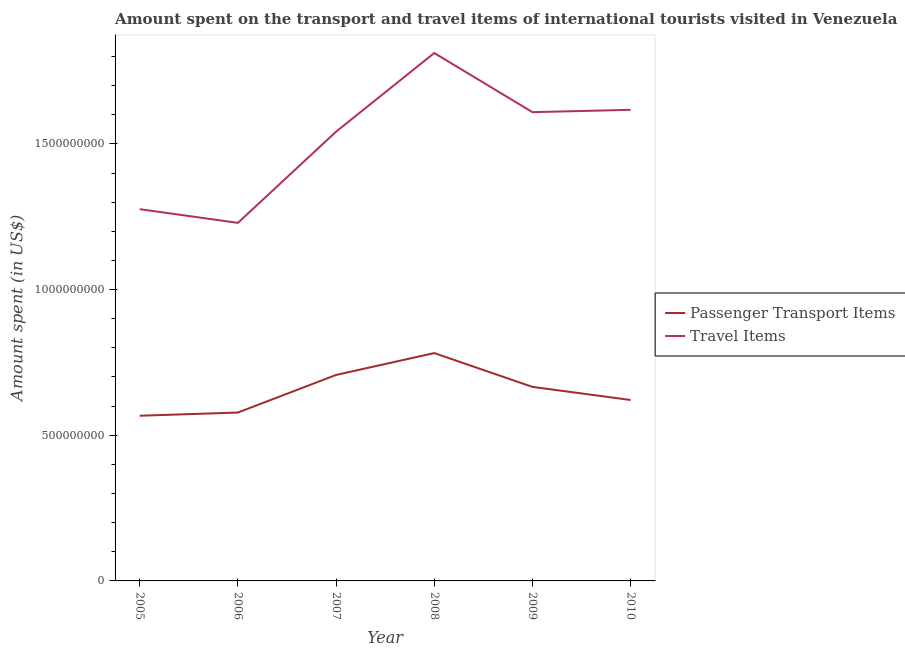Does the line corresponding to amount spent on passenger transport items intersect with the line corresponding to amount spent in travel items?
Make the answer very short. No. Is the number of lines equal to the number of legend labels?
Provide a short and direct response. Yes. What is the amount spent in travel items in 2010?
Provide a succinct answer. 1.62e+09. Across all years, what is the maximum amount spent in travel items?
Give a very brief answer. 1.81e+09. Across all years, what is the minimum amount spent on passenger transport items?
Your answer should be compact. 5.67e+08. In which year was the amount spent on passenger transport items maximum?
Provide a succinct answer. 2008. What is the total amount spent on passenger transport items in the graph?
Your response must be concise. 3.92e+09. What is the difference between the amount spent in travel items in 2005 and that in 2009?
Ensure brevity in your answer.  -3.33e+08. What is the difference between the amount spent in travel items in 2006 and the amount spent on passenger transport items in 2009?
Provide a succinct answer. 5.63e+08. What is the average amount spent in travel items per year?
Offer a very short reply. 1.51e+09. In the year 2009, what is the difference between the amount spent on passenger transport items and amount spent in travel items?
Your answer should be compact. -9.43e+08. What is the ratio of the amount spent on passenger transport items in 2005 to that in 2009?
Your answer should be very brief. 0.85. What is the difference between the highest and the second highest amount spent on passenger transport items?
Provide a short and direct response. 7.50e+07. What is the difference between the highest and the lowest amount spent in travel items?
Offer a very short reply. 5.83e+08. Is the sum of the amount spent in travel items in 2006 and 2008 greater than the maximum amount spent on passenger transport items across all years?
Make the answer very short. Yes. Is the amount spent in travel items strictly less than the amount spent on passenger transport items over the years?
Provide a short and direct response. No. How many years are there in the graph?
Give a very brief answer. 6. Are the values on the major ticks of Y-axis written in scientific E-notation?
Make the answer very short. No. Where does the legend appear in the graph?
Your answer should be very brief. Center right. How are the legend labels stacked?
Keep it short and to the point. Vertical. What is the title of the graph?
Provide a succinct answer. Amount spent on the transport and travel items of international tourists visited in Venezuela. What is the label or title of the Y-axis?
Make the answer very short. Amount spent (in US$). What is the Amount spent (in US$) of Passenger Transport Items in 2005?
Keep it short and to the point. 5.67e+08. What is the Amount spent (in US$) in Travel Items in 2005?
Make the answer very short. 1.28e+09. What is the Amount spent (in US$) in Passenger Transport Items in 2006?
Provide a succinct answer. 5.78e+08. What is the Amount spent (in US$) in Travel Items in 2006?
Provide a short and direct response. 1.23e+09. What is the Amount spent (in US$) of Passenger Transport Items in 2007?
Offer a terse response. 7.07e+08. What is the Amount spent (in US$) in Travel Items in 2007?
Provide a short and direct response. 1.54e+09. What is the Amount spent (in US$) in Passenger Transport Items in 2008?
Offer a very short reply. 7.82e+08. What is the Amount spent (in US$) in Travel Items in 2008?
Offer a very short reply. 1.81e+09. What is the Amount spent (in US$) of Passenger Transport Items in 2009?
Your response must be concise. 6.66e+08. What is the Amount spent (in US$) of Travel Items in 2009?
Give a very brief answer. 1.61e+09. What is the Amount spent (in US$) in Passenger Transport Items in 2010?
Provide a short and direct response. 6.21e+08. What is the Amount spent (in US$) in Travel Items in 2010?
Your answer should be compact. 1.62e+09. Across all years, what is the maximum Amount spent (in US$) in Passenger Transport Items?
Provide a short and direct response. 7.82e+08. Across all years, what is the maximum Amount spent (in US$) in Travel Items?
Your answer should be compact. 1.81e+09. Across all years, what is the minimum Amount spent (in US$) in Passenger Transport Items?
Your response must be concise. 5.67e+08. Across all years, what is the minimum Amount spent (in US$) of Travel Items?
Provide a succinct answer. 1.23e+09. What is the total Amount spent (in US$) of Passenger Transport Items in the graph?
Your response must be concise. 3.92e+09. What is the total Amount spent (in US$) in Travel Items in the graph?
Give a very brief answer. 9.08e+09. What is the difference between the Amount spent (in US$) of Passenger Transport Items in 2005 and that in 2006?
Keep it short and to the point. -1.10e+07. What is the difference between the Amount spent (in US$) in Travel Items in 2005 and that in 2006?
Keep it short and to the point. 4.70e+07. What is the difference between the Amount spent (in US$) in Passenger Transport Items in 2005 and that in 2007?
Provide a succinct answer. -1.40e+08. What is the difference between the Amount spent (in US$) of Travel Items in 2005 and that in 2007?
Make the answer very short. -2.66e+08. What is the difference between the Amount spent (in US$) in Passenger Transport Items in 2005 and that in 2008?
Make the answer very short. -2.15e+08. What is the difference between the Amount spent (in US$) in Travel Items in 2005 and that in 2008?
Give a very brief answer. -5.36e+08. What is the difference between the Amount spent (in US$) of Passenger Transport Items in 2005 and that in 2009?
Make the answer very short. -9.90e+07. What is the difference between the Amount spent (in US$) in Travel Items in 2005 and that in 2009?
Your answer should be compact. -3.33e+08. What is the difference between the Amount spent (in US$) in Passenger Transport Items in 2005 and that in 2010?
Provide a short and direct response. -5.40e+07. What is the difference between the Amount spent (in US$) in Travel Items in 2005 and that in 2010?
Offer a very short reply. -3.41e+08. What is the difference between the Amount spent (in US$) in Passenger Transport Items in 2006 and that in 2007?
Offer a terse response. -1.29e+08. What is the difference between the Amount spent (in US$) of Travel Items in 2006 and that in 2007?
Your answer should be very brief. -3.13e+08. What is the difference between the Amount spent (in US$) of Passenger Transport Items in 2006 and that in 2008?
Provide a succinct answer. -2.04e+08. What is the difference between the Amount spent (in US$) in Travel Items in 2006 and that in 2008?
Give a very brief answer. -5.83e+08. What is the difference between the Amount spent (in US$) of Passenger Transport Items in 2006 and that in 2009?
Offer a terse response. -8.80e+07. What is the difference between the Amount spent (in US$) of Travel Items in 2006 and that in 2009?
Provide a succinct answer. -3.80e+08. What is the difference between the Amount spent (in US$) in Passenger Transport Items in 2006 and that in 2010?
Keep it short and to the point. -4.30e+07. What is the difference between the Amount spent (in US$) in Travel Items in 2006 and that in 2010?
Provide a succinct answer. -3.88e+08. What is the difference between the Amount spent (in US$) in Passenger Transport Items in 2007 and that in 2008?
Your response must be concise. -7.50e+07. What is the difference between the Amount spent (in US$) in Travel Items in 2007 and that in 2008?
Provide a succinct answer. -2.70e+08. What is the difference between the Amount spent (in US$) of Passenger Transport Items in 2007 and that in 2009?
Your response must be concise. 4.10e+07. What is the difference between the Amount spent (in US$) of Travel Items in 2007 and that in 2009?
Your answer should be compact. -6.70e+07. What is the difference between the Amount spent (in US$) in Passenger Transport Items in 2007 and that in 2010?
Provide a succinct answer. 8.60e+07. What is the difference between the Amount spent (in US$) of Travel Items in 2007 and that in 2010?
Offer a very short reply. -7.50e+07. What is the difference between the Amount spent (in US$) of Passenger Transport Items in 2008 and that in 2009?
Provide a short and direct response. 1.16e+08. What is the difference between the Amount spent (in US$) in Travel Items in 2008 and that in 2009?
Keep it short and to the point. 2.03e+08. What is the difference between the Amount spent (in US$) of Passenger Transport Items in 2008 and that in 2010?
Keep it short and to the point. 1.61e+08. What is the difference between the Amount spent (in US$) in Travel Items in 2008 and that in 2010?
Keep it short and to the point. 1.95e+08. What is the difference between the Amount spent (in US$) in Passenger Transport Items in 2009 and that in 2010?
Your response must be concise. 4.50e+07. What is the difference between the Amount spent (in US$) in Travel Items in 2009 and that in 2010?
Your answer should be very brief. -8.00e+06. What is the difference between the Amount spent (in US$) in Passenger Transport Items in 2005 and the Amount spent (in US$) in Travel Items in 2006?
Your answer should be compact. -6.62e+08. What is the difference between the Amount spent (in US$) in Passenger Transport Items in 2005 and the Amount spent (in US$) in Travel Items in 2007?
Your answer should be compact. -9.75e+08. What is the difference between the Amount spent (in US$) of Passenger Transport Items in 2005 and the Amount spent (in US$) of Travel Items in 2008?
Offer a very short reply. -1.24e+09. What is the difference between the Amount spent (in US$) of Passenger Transport Items in 2005 and the Amount spent (in US$) of Travel Items in 2009?
Provide a short and direct response. -1.04e+09. What is the difference between the Amount spent (in US$) of Passenger Transport Items in 2005 and the Amount spent (in US$) of Travel Items in 2010?
Provide a succinct answer. -1.05e+09. What is the difference between the Amount spent (in US$) of Passenger Transport Items in 2006 and the Amount spent (in US$) of Travel Items in 2007?
Ensure brevity in your answer.  -9.64e+08. What is the difference between the Amount spent (in US$) of Passenger Transport Items in 2006 and the Amount spent (in US$) of Travel Items in 2008?
Make the answer very short. -1.23e+09. What is the difference between the Amount spent (in US$) in Passenger Transport Items in 2006 and the Amount spent (in US$) in Travel Items in 2009?
Keep it short and to the point. -1.03e+09. What is the difference between the Amount spent (in US$) of Passenger Transport Items in 2006 and the Amount spent (in US$) of Travel Items in 2010?
Your answer should be compact. -1.04e+09. What is the difference between the Amount spent (in US$) in Passenger Transport Items in 2007 and the Amount spent (in US$) in Travel Items in 2008?
Make the answer very short. -1.10e+09. What is the difference between the Amount spent (in US$) in Passenger Transport Items in 2007 and the Amount spent (in US$) in Travel Items in 2009?
Your answer should be very brief. -9.02e+08. What is the difference between the Amount spent (in US$) of Passenger Transport Items in 2007 and the Amount spent (in US$) of Travel Items in 2010?
Your response must be concise. -9.10e+08. What is the difference between the Amount spent (in US$) in Passenger Transport Items in 2008 and the Amount spent (in US$) in Travel Items in 2009?
Your answer should be compact. -8.27e+08. What is the difference between the Amount spent (in US$) of Passenger Transport Items in 2008 and the Amount spent (in US$) of Travel Items in 2010?
Give a very brief answer. -8.35e+08. What is the difference between the Amount spent (in US$) in Passenger Transport Items in 2009 and the Amount spent (in US$) in Travel Items in 2010?
Provide a short and direct response. -9.51e+08. What is the average Amount spent (in US$) in Passenger Transport Items per year?
Offer a very short reply. 6.54e+08. What is the average Amount spent (in US$) of Travel Items per year?
Provide a short and direct response. 1.51e+09. In the year 2005, what is the difference between the Amount spent (in US$) of Passenger Transport Items and Amount spent (in US$) of Travel Items?
Your response must be concise. -7.09e+08. In the year 2006, what is the difference between the Amount spent (in US$) in Passenger Transport Items and Amount spent (in US$) in Travel Items?
Keep it short and to the point. -6.51e+08. In the year 2007, what is the difference between the Amount spent (in US$) of Passenger Transport Items and Amount spent (in US$) of Travel Items?
Provide a short and direct response. -8.35e+08. In the year 2008, what is the difference between the Amount spent (in US$) of Passenger Transport Items and Amount spent (in US$) of Travel Items?
Keep it short and to the point. -1.03e+09. In the year 2009, what is the difference between the Amount spent (in US$) of Passenger Transport Items and Amount spent (in US$) of Travel Items?
Give a very brief answer. -9.43e+08. In the year 2010, what is the difference between the Amount spent (in US$) of Passenger Transport Items and Amount spent (in US$) of Travel Items?
Offer a terse response. -9.96e+08. What is the ratio of the Amount spent (in US$) in Travel Items in 2005 to that in 2006?
Offer a very short reply. 1.04. What is the ratio of the Amount spent (in US$) of Passenger Transport Items in 2005 to that in 2007?
Offer a terse response. 0.8. What is the ratio of the Amount spent (in US$) of Travel Items in 2005 to that in 2007?
Your answer should be compact. 0.83. What is the ratio of the Amount spent (in US$) in Passenger Transport Items in 2005 to that in 2008?
Your answer should be very brief. 0.73. What is the ratio of the Amount spent (in US$) in Travel Items in 2005 to that in 2008?
Give a very brief answer. 0.7. What is the ratio of the Amount spent (in US$) of Passenger Transport Items in 2005 to that in 2009?
Your answer should be very brief. 0.85. What is the ratio of the Amount spent (in US$) of Travel Items in 2005 to that in 2009?
Keep it short and to the point. 0.79. What is the ratio of the Amount spent (in US$) of Passenger Transport Items in 2005 to that in 2010?
Provide a succinct answer. 0.91. What is the ratio of the Amount spent (in US$) in Travel Items in 2005 to that in 2010?
Your answer should be very brief. 0.79. What is the ratio of the Amount spent (in US$) in Passenger Transport Items in 2006 to that in 2007?
Provide a succinct answer. 0.82. What is the ratio of the Amount spent (in US$) of Travel Items in 2006 to that in 2007?
Provide a succinct answer. 0.8. What is the ratio of the Amount spent (in US$) of Passenger Transport Items in 2006 to that in 2008?
Your answer should be very brief. 0.74. What is the ratio of the Amount spent (in US$) in Travel Items in 2006 to that in 2008?
Offer a terse response. 0.68. What is the ratio of the Amount spent (in US$) in Passenger Transport Items in 2006 to that in 2009?
Ensure brevity in your answer.  0.87. What is the ratio of the Amount spent (in US$) of Travel Items in 2006 to that in 2009?
Keep it short and to the point. 0.76. What is the ratio of the Amount spent (in US$) of Passenger Transport Items in 2006 to that in 2010?
Your answer should be very brief. 0.93. What is the ratio of the Amount spent (in US$) of Travel Items in 2006 to that in 2010?
Your response must be concise. 0.76. What is the ratio of the Amount spent (in US$) in Passenger Transport Items in 2007 to that in 2008?
Keep it short and to the point. 0.9. What is the ratio of the Amount spent (in US$) in Travel Items in 2007 to that in 2008?
Keep it short and to the point. 0.85. What is the ratio of the Amount spent (in US$) in Passenger Transport Items in 2007 to that in 2009?
Ensure brevity in your answer.  1.06. What is the ratio of the Amount spent (in US$) in Travel Items in 2007 to that in 2009?
Give a very brief answer. 0.96. What is the ratio of the Amount spent (in US$) in Passenger Transport Items in 2007 to that in 2010?
Your answer should be compact. 1.14. What is the ratio of the Amount spent (in US$) in Travel Items in 2007 to that in 2010?
Make the answer very short. 0.95. What is the ratio of the Amount spent (in US$) in Passenger Transport Items in 2008 to that in 2009?
Ensure brevity in your answer.  1.17. What is the ratio of the Amount spent (in US$) in Travel Items in 2008 to that in 2009?
Keep it short and to the point. 1.13. What is the ratio of the Amount spent (in US$) in Passenger Transport Items in 2008 to that in 2010?
Your response must be concise. 1.26. What is the ratio of the Amount spent (in US$) of Travel Items in 2008 to that in 2010?
Your response must be concise. 1.12. What is the ratio of the Amount spent (in US$) in Passenger Transport Items in 2009 to that in 2010?
Provide a short and direct response. 1.07. What is the ratio of the Amount spent (in US$) of Travel Items in 2009 to that in 2010?
Give a very brief answer. 1. What is the difference between the highest and the second highest Amount spent (in US$) of Passenger Transport Items?
Offer a very short reply. 7.50e+07. What is the difference between the highest and the second highest Amount spent (in US$) of Travel Items?
Make the answer very short. 1.95e+08. What is the difference between the highest and the lowest Amount spent (in US$) in Passenger Transport Items?
Provide a succinct answer. 2.15e+08. What is the difference between the highest and the lowest Amount spent (in US$) in Travel Items?
Offer a terse response. 5.83e+08. 